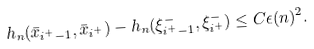<formula> <loc_0><loc_0><loc_500><loc_500>h _ { n } ( \bar { x } _ { i ^ { + } - 1 } , \bar { x } _ { i ^ { + } } ) - h _ { n } ( \xi _ { i ^ { + } - 1 } ^ { - } , \xi _ { i ^ { + } } ^ { - } ) \leq C \epsilon ( n ) ^ { 2 } .</formula> 